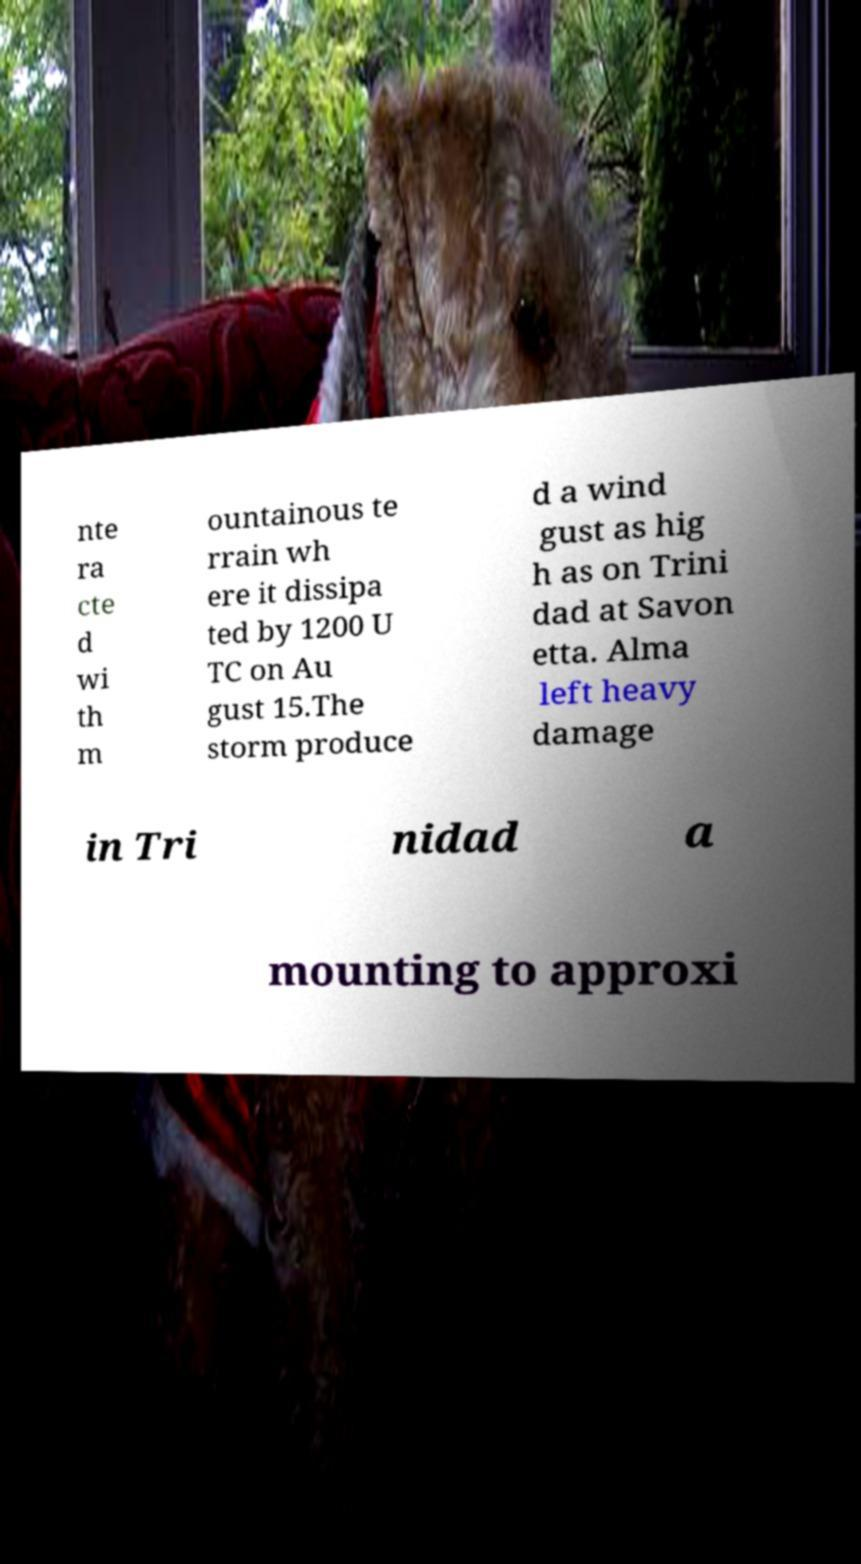I need the written content from this picture converted into text. Can you do that? nte ra cte d wi th m ountainous te rrain wh ere it dissipa ted by 1200 U TC on Au gust 15.The storm produce d a wind gust as hig h as on Trini dad at Savon etta. Alma left heavy damage in Tri nidad a mounting to approxi 